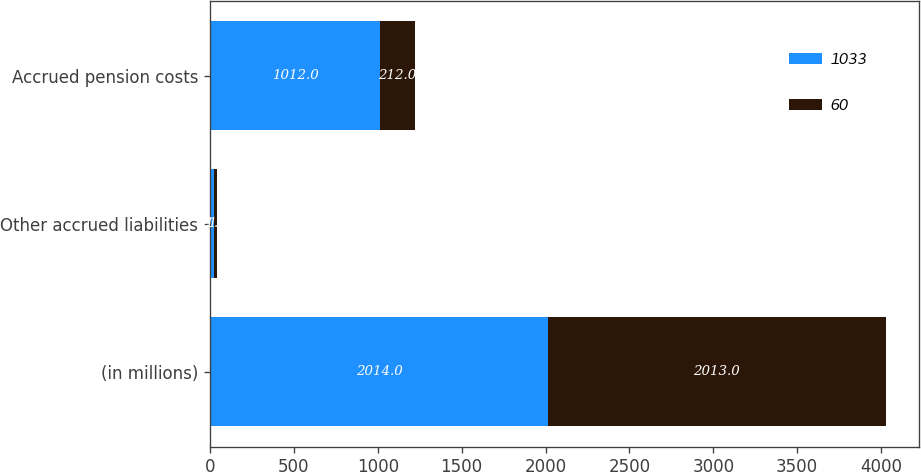Convert chart to OTSL. <chart><loc_0><loc_0><loc_500><loc_500><stacked_bar_chart><ecel><fcel>(in millions)<fcel>Other accrued liabilities<fcel>Accrued pension costs<nl><fcel>1033<fcel>2014<fcel>21<fcel>1012<nl><fcel>60<fcel>2013<fcel>21<fcel>212<nl></chart> 